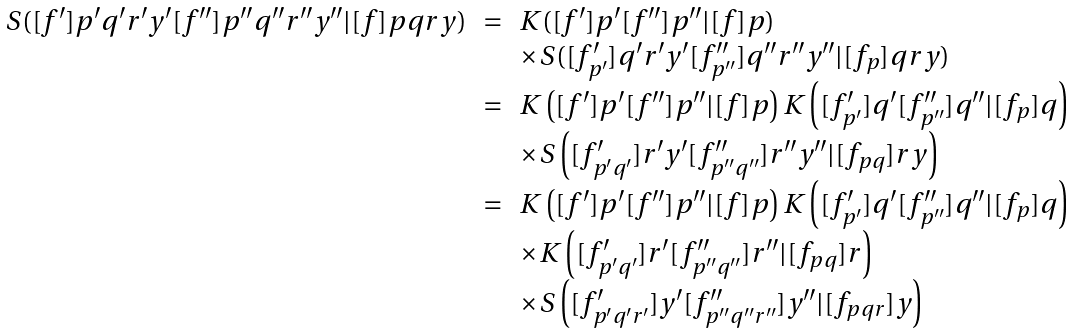Convert formula to latex. <formula><loc_0><loc_0><loc_500><loc_500>\begin{array} { l c l } S ( [ f ^ { \prime } ] p ^ { \prime } q ^ { \prime } r ^ { \prime } y ^ { \prime } [ f ^ { \prime \prime } ] p ^ { \prime \prime } q ^ { \prime \prime } r ^ { \prime \prime } y ^ { \prime \prime } | [ f ] p q r y ) & = & K ( [ f ^ { \prime } ] p ^ { \prime } [ f ^ { \prime \prime } ] p ^ { \prime \prime } | [ f ] p ) \\ & & \times S ( [ f ^ { \prime } _ { p ^ { \prime } } ] q ^ { \prime } r ^ { \prime } y ^ { \prime } [ f ^ { \prime \prime } _ { p ^ { \prime \prime } } ] q ^ { \prime \prime } r ^ { \prime \prime } y ^ { \prime \prime } | [ f _ { p } ] q r y ) \\ & = & K \left ( [ f ^ { \prime } ] p ^ { \prime } [ f ^ { \prime \prime } ] p ^ { \prime \prime } | [ f ] p \right ) K \left ( [ f ^ { \prime } _ { p ^ { \prime } } ] q ^ { \prime } [ f ^ { \prime \prime } _ { p ^ { \prime \prime } } ] q ^ { \prime \prime } | [ f _ { p } ] q \right ) \\ & & \times S \left ( [ f ^ { \prime } _ { p ^ { \prime } q ^ { \prime } } ] r ^ { \prime } y ^ { \prime } [ f ^ { \prime \prime } _ { p ^ { \prime \prime } q ^ { \prime \prime } } ] r ^ { \prime \prime } y ^ { \prime \prime } | [ f _ { p q } ] r y \right ) \\ & = & K \left ( [ f ^ { \prime } ] p ^ { \prime } [ f ^ { \prime \prime } ] p ^ { \prime \prime } | [ f ] p \right ) K \left ( [ f ^ { \prime } _ { p ^ { \prime } } ] q ^ { \prime } [ f ^ { \prime \prime } _ { p ^ { \prime \prime } } ] q ^ { \prime \prime } | [ f _ { p } ] q \right ) \\ & & \times K \left ( [ f ^ { \prime } _ { p ^ { \prime } q ^ { \prime } } ] r ^ { \prime } [ f ^ { \prime \prime } _ { p ^ { \prime \prime } q ^ { \prime \prime } } ] r ^ { \prime \prime } | [ f _ { p q } ] r \right ) \\ & & \times S \left ( [ f ^ { \prime } _ { p ^ { \prime } q ^ { \prime } r ^ { \prime } } ] y ^ { \prime } [ f ^ { \prime \prime } _ { p ^ { \prime \prime } q ^ { \prime \prime } r ^ { \prime \prime } } ] y ^ { \prime \prime } | [ f _ { p q r } ] y \right ) \end{array}</formula> 